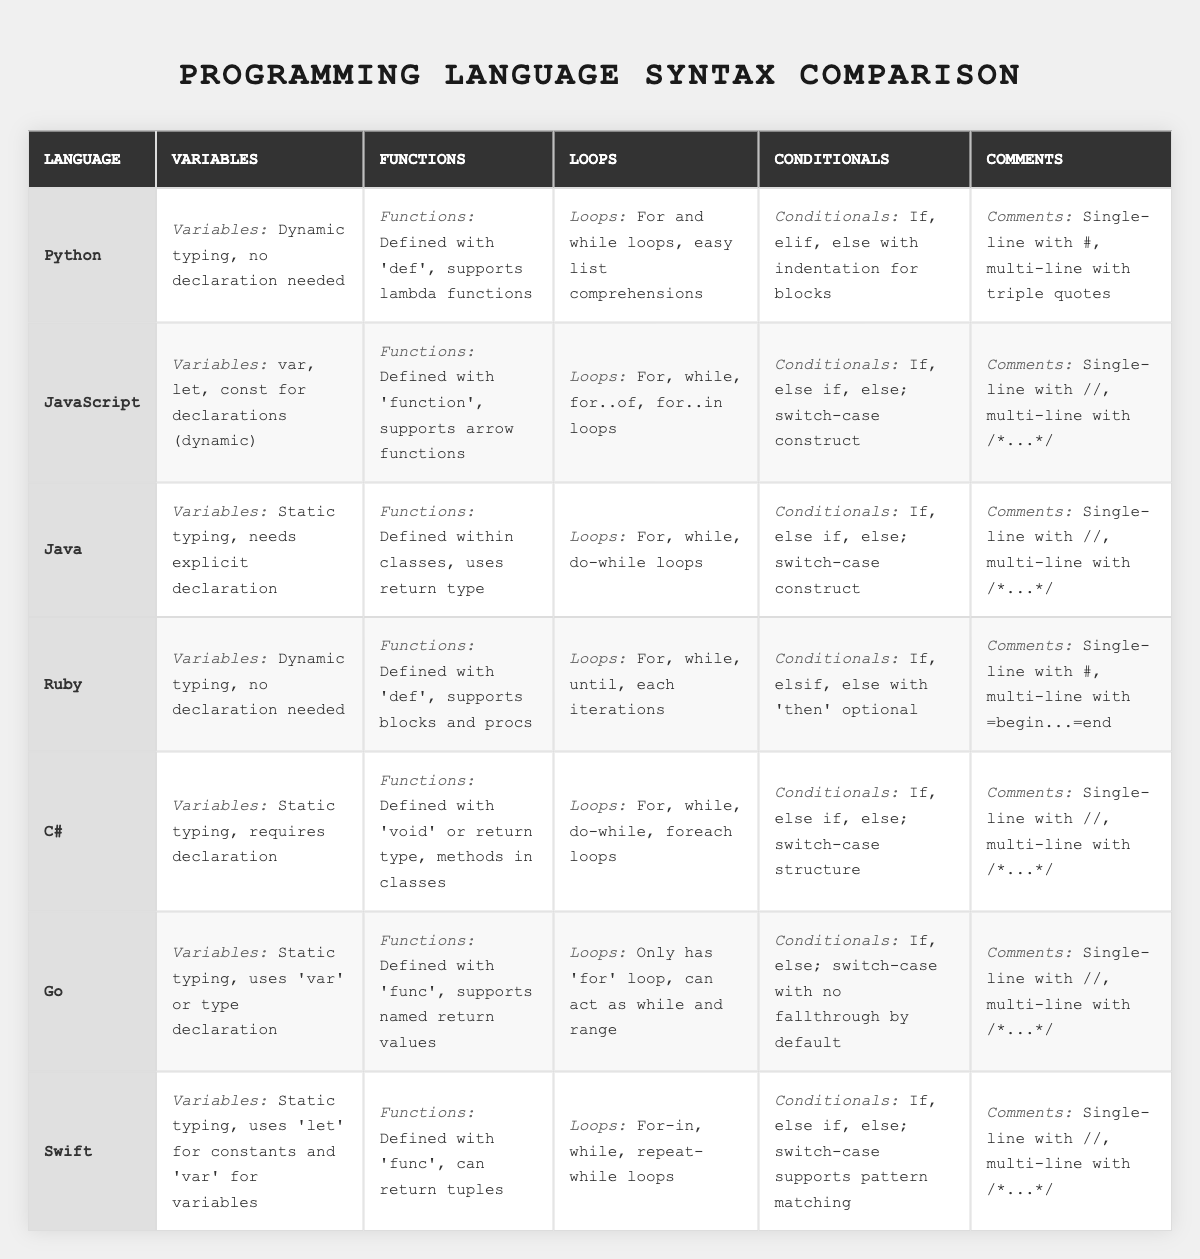What are the variables in Python? The table indicates that Python uses dynamic typing and does not require declaration for variables.
Answer: Dynamic typing, no declaration needed Which language requires explicit declaration for variables? By observing the table, Java, C#, and Go clearly specify that they require explicit declarations for their variables.
Answer: Java, C#, Go Does Ruby support lambda functions? The table specifies that Ruby functions can be defined with 'def' and supports blocks and procs, but does not mention lambda functions. So the answer is no.
Answer: No Which programming language does not have a traditional loop construct? The table shows that Go only has a 'for' loop which can act as while and range, implying it does not have traditional separate loops like 'while' or 'do-while'.
Answer: Go How many programming languages listed use static typing? Reviewing the table, Java, C#, Go, and Swift are indicated to use static typing. This counts to four languages.
Answer: Four What is the main difference in functions between Python and C#? The table shows that Python defines functions with 'def' and supports lambda functions, while C# defines functions within classes and requires a return type.
Answer: Functions defined differently; C# requires return type and is class-based Which languages support both single and multi-line comments? In the table, the languages that allow both types of comments are JavaScript, Java, C#, Go, and Swift.
Answer: JavaScript, Java, C#, Go, Swift What unique feature does Go support in its functions? According to the table, Go functions can return named values, which is a unique feature not mentioned for other languages.
Answer: Named return values Which languages have 'if' statements structured similarly? The table indicates that Python, JavaScript, Java, Ruby, C#, and Swift have similar 'if' statement structures, using 'if', 'else if', and 'else' statements.
Answer: Python, JavaScript, Java, Ruby, C#, Swift Which two languages have the most comment styles listed? The table reveals that both Java and C# support single-line and multi-line comments, which are the same styles listed. Both languages highlight this in their descriptions.
Answer: Java, C# How does the concept of loops differ the most between Python and Go? The key distinction is that Python has both 'for' and 'while' loops along with easy list comprehensions, while Go only has a 'for' loop which can function as while and range implications.
Answer: Python has more loop types; Go has only 'for' loop 